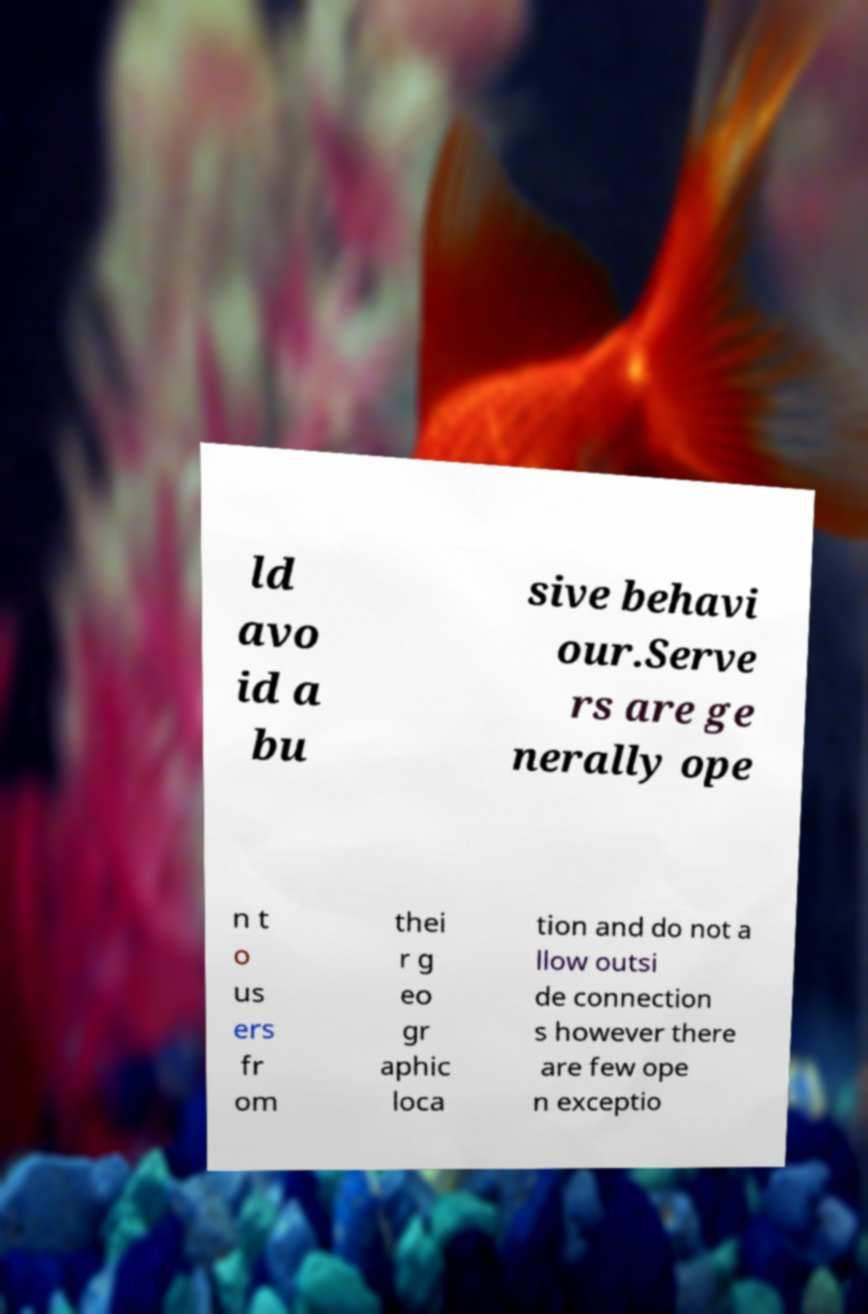Please read and relay the text visible in this image. What does it say? ld avo id a bu sive behavi our.Serve rs are ge nerally ope n t o us ers fr om thei r g eo gr aphic loca tion and do not a llow outsi de connection s however there are few ope n exceptio 